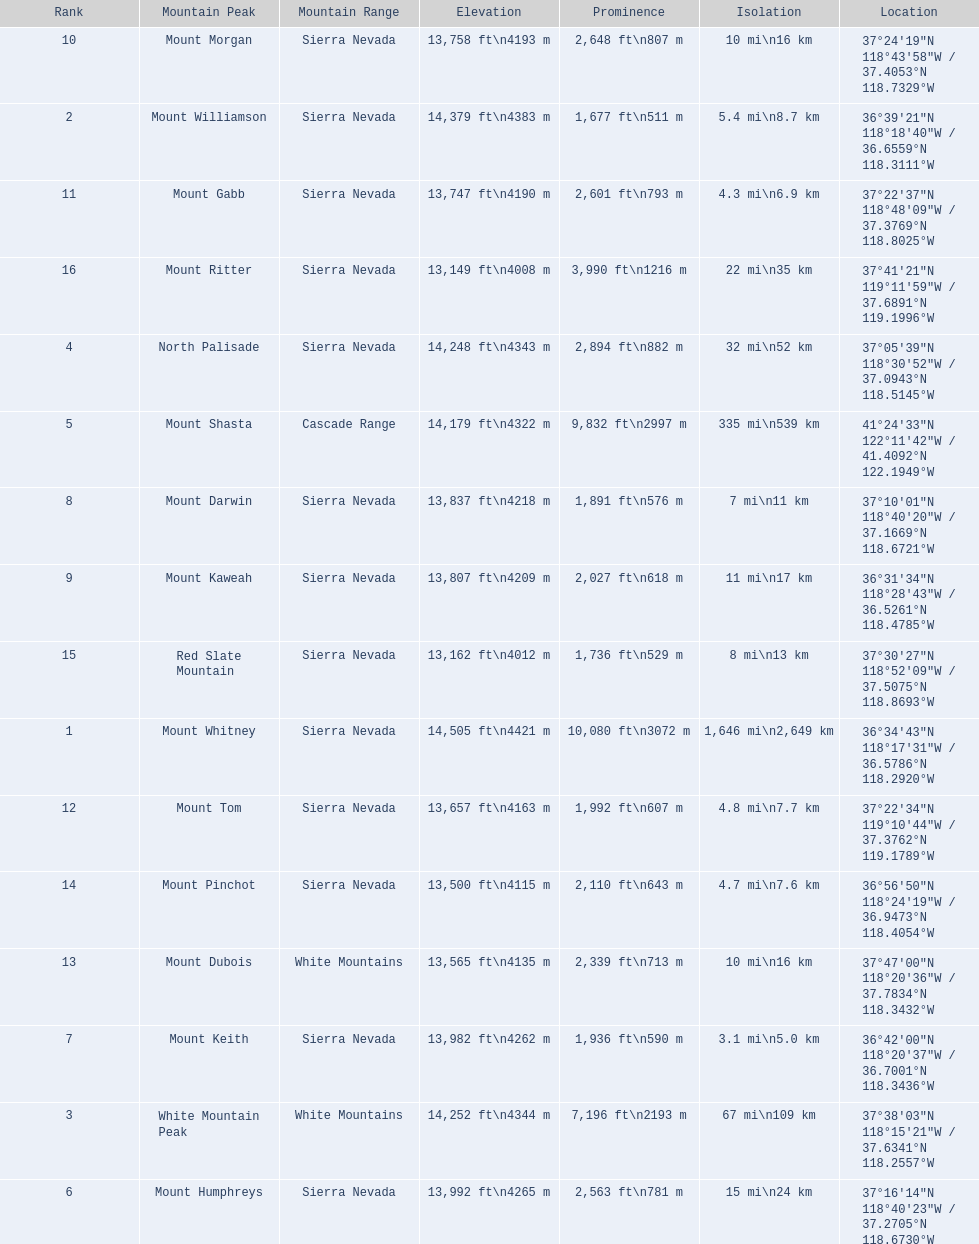What are the prominence lengths higher than 10,000 feet? 10,080 ft\n3072 m. What mountain peak has a prominence of 10,080 feet? Mount Whitney. 